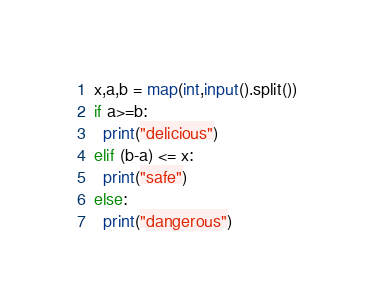<code> <loc_0><loc_0><loc_500><loc_500><_Python_>x,a,b = map(int,input().split())
if a>=b:
  print("delicious")
elif (b-a) <= x:
  print("safe")
else:
  print("dangerous")</code> 